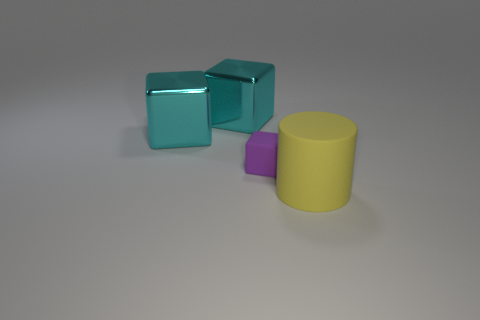What's the lighting like in this scene? The lighting of the scene appears soft and diffused, casting gentle shadows on the right side of the objects, indicative of an evenly lit environment with probable overhead light sources. 